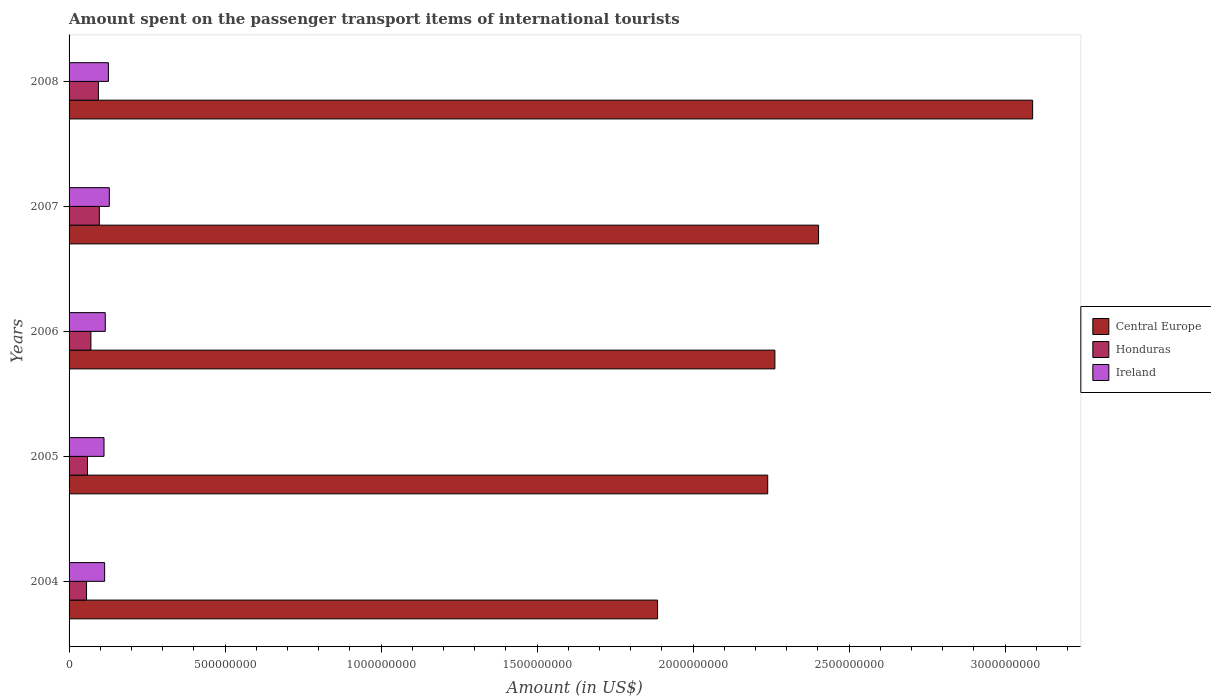How many different coloured bars are there?
Your response must be concise. 3. How many groups of bars are there?
Offer a terse response. 5. Are the number of bars on each tick of the Y-axis equal?
Your answer should be very brief. Yes. How many bars are there on the 5th tick from the top?
Provide a short and direct response. 3. How many bars are there on the 4th tick from the bottom?
Make the answer very short. 3. What is the label of the 5th group of bars from the top?
Offer a very short reply. 2004. In how many cases, is the number of bars for a given year not equal to the number of legend labels?
Give a very brief answer. 0. What is the amount spent on the passenger transport items of international tourists in Central Europe in 2007?
Keep it short and to the point. 2.40e+09. Across all years, what is the maximum amount spent on the passenger transport items of international tourists in Central Europe?
Your answer should be very brief. 3.09e+09. Across all years, what is the minimum amount spent on the passenger transport items of international tourists in Ireland?
Ensure brevity in your answer.  1.12e+08. In which year was the amount spent on the passenger transport items of international tourists in Central Europe maximum?
Offer a terse response. 2008. What is the total amount spent on the passenger transport items of international tourists in Honduras in the graph?
Provide a short and direct response. 3.76e+08. What is the difference between the amount spent on the passenger transport items of international tourists in Honduras in 2004 and that in 2005?
Offer a terse response. -3.00e+06. What is the difference between the amount spent on the passenger transport items of international tourists in Ireland in 2008 and the amount spent on the passenger transport items of international tourists in Honduras in 2007?
Ensure brevity in your answer.  2.90e+07. What is the average amount spent on the passenger transport items of international tourists in Ireland per year?
Provide a succinct answer. 1.19e+08. In the year 2008, what is the difference between the amount spent on the passenger transport items of international tourists in Central Europe and amount spent on the passenger transport items of international tourists in Honduras?
Offer a terse response. 2.99e+09. In how many years, is the amount spent on the passenger transport items of international tourists in Honduras greater than 200000000 US$?
Your response must be concise. 0. What is the ratio of the amount spent on the passenger transport items of international tourists in Ireland in 2005 to that in 2006?
Provide a short and direct response. 0.97. Is the amount spent on the passenger transport items of international tourists in Honduras in 2004 less than that in 2006?
Offer a very short reply. Yes. Is the difference between the amount spent on the passenger transport items of international tourists in Central Europe in 2005 and 2006 greater than the difference between the amount spent on the passenger transport items of international tourists in Honduras in 2005 and 2006?
Offer a terse response. No. What is the difference between the highest and the lowest amount spent on the passenger transport items of international tourists in Ireland?
Provide a succinct answer. 1.70e+07. In how many years, is the amount spent on the passenger transport items of international tourists in Honduras greater than the average amount spent on the passenger transport items of international tourists in Honduras taken over all years?
Provide a short and direct response. 2. Is the sum of the amount spent on the passenger transport items of international tourists in Central Europe in 2005 and 2008 greater than the maximum amount spent on the passenger transport items of international tourists in Honduras across all years?
Give a very brief answer. Yes. What does the 3rd bar from the top in 2008 represents?
Provide a succinct answer. Central Europe. What does the 3rd bar from the bottom in 2004 represents?
Ensure brevity in your answer.  Ireland. How many years are there in the graph?
Keep it short and to the point. 5. What is the difference between two consecutive major ticks on the X-axis?
Give a very brief answer. 5.00e+08. Are the values on the major ticks of X-axis written in scientific E-notation?
Keep it short and to the point. No. Does the graph contain any zero values?
Provide a short and direct response. No. Does the graph contain grids?
Offer a terse response. No. Where does the legend appear in the graph?
Keep it short and to the point. Center right. How are the legend labels stacked?
Your answer should be very brief. Vertical. What is the title of the graph?
Keep it short and to the point. Amount spent on the passenger transport items of international tourists. What is the Amount (in US$) of Central Europe in 2004?
Ensure brevity in your answer.  1.89e+09. What is the Amount (in US$) of Honduras in 2004?
Your answer should be very brief. 5.60e+07. What is the Amount (in US$) of Ireland in 2004?
Provide a short and direct response. 1.14e+08. What is the Amount (in US$) in Central Europe in 2005?
Provide a short and direct response. 2.24e+09. What is the Amount (in US$) of Honduras in 2005?
Keep it short and to the point. 5.90e+07. What is the Amount (in US$) in Ireland in 2005?
Offer a very short reply. 1.12e+08. What is the Amount (in US$) in Central Europe in 2006?
Keep it short and to the point. 2.26e+09. What is the Amount (in US$) of Honduras in 2006?
Make the answer very short. 7.00e+07. What is the Amount (in US$) of Ireland in 2006?
Offer a very short reply. 1.16e+08. What is the Amount (in US$) of Central Europe in 2007?
Your response must be concise. 2.40e+09. What is the Amount (in US$) in Honduras in 2007?
Ensure brevity in your answer.  9.70e+07. What is the Amount (in US$) in Ireland in 2007?
Provide a succinct answer. 1.29e+08. What is the Amount (in US$) of Central Europe in 2008?
Keep it short and to the point. 3.09e+09. What is the Amount (in US$) in Honduras in 2008?
Provide a short and direct response. 9.40e+07. What is the Amount (in US$) of Ireland in 2008?
Your answer should be compact. 1.26e+08. Across all years, what is the maximum Amount (in US$) in Central Europe?
Provide a succinct answer. 3.09e+09. Across all years, what is the maximum Amount (in US$) in Honduras?
Your answer should be compact. 9.70e+07. Across all years, what is the maximum Amount (in US$) in Ireland?
Provide a succinct answer. 1.29e+08. Across all years, what is the minimum Amount (in US$) of Central Europe?
Your response must be concise. 1.89e+09. Across all years, what is the minimum Amount (in US$) of Honduras?
Your answer should be very brief. 5.60e+07. Across all years, what is the minimum Amount (in US$) of Ireland?
Ensure brevity in your answer.  1.12e+08. What is the total Amount (in US$) of Central Europe in the graph?
Your answer should be compact. 1.19e+1. What is the total Amount (in US$) in Honduras in the graph?
Ensure brevity in your answer.  3.76e+08. What is the total Amount (in US$) in Ireland in the graph?
Provide a succinct answer. 5.97e+08. What is the difference between the Amount (in US$) in Central Europe in 2004 and that in 2005?
Ensure brevity in your answer.  -3.53e+08. What is the difference between the Amount (in US$) of Honduras in 2004 and that in 2005?
Make the answer very short. -3.00e+06. What is the difference between the Amount (in US$) in Central Europe in 2004 and that in 2006?
Ensure brevity in your answer.  -3.76e+08. What is the difference between the Amount (in US$) in Honduras in 2004 and that in 2006?
Ensure brevity in your answer.  -1.40e+07. What is the difference between the Amount (in US$) of Ireland in 2004 and that in 2006?
Provide a short and direct response. -2.00e+06. What is the difference between the Amount (in US$) in Central Europe in 2004 and that in 2007?
Offer a terse response. -5.16e+08. What is the difference between the Amount (in US$) in Honduras in 2004 and that in 2007?
Your response must be concise. -4.10e+07. What is the difference between the Amount (in US$) in Ireland in 2004 and that in 2007?
Offer a terse response. -1.50e+07. What is the difference between the Amount (in US$) of Central Europe in 2004 and that in 2008?
Your response must be concise. -1.20e+09. What is the difference between the Amount (in US$) of Honduras in 2004 and that in 2008?
Your answer should be very brief. -3.80e+07. What is the difference between the Amount (in US$) of Ireland in 2004 and that in 2008?
Ensure brevity in your answer.  -1.20e+07. What is the difference between the Amount (in US$) in Central Europe in 2005 and that in 2006?
Your response must be concise. -2.30e+07. What is the difference between the Amount (in US$) of Honduras in 2005 and that in 2006?
Keep it short and to the point. -1.10e+07. What is the difference between the Amount (in US$) of Central Europe in 2005 and that in 2007?
Your answer should be compact. -1.63e+08. What is the difference between the Amount (in US$) in Honduras in 2005 and that in 2007?
Your answer should be very brief. -3.80e+07. What is the difference between the Amount (in US$) in Ireland in 2005 and that in 2007?
Keep it short and to the point. -1.70e+07. What is the difference between the Amount (in US$) of Central Europe in 2005 and that in 2008?
Provide a succinct answer. -8.49e+08. What is the difference between the Amount (in US$) in Honduras in 2005 and that in 2008?
Provide a succinct answer. -3.50e+07. What is the difference between the Amount (in US$) of Ireland in 2005 and that in 2008?
Your response must be concise. -1.40e+07. What is the difference between the Amount (in US$) of Central Europe in 2006 and that in 2007?
Your answer should be very brief. -1.40e+08. What is the difference between the Amount (in US$) in Honduras in 2006 and that in 2007?
Give a very brief answer. -2.70e+07. What is the difference between the Amount (in US$) of Ireland in 2006 and that in 2007?
Keep it short and to the point. -1.30e+07. What is the difference between the Amount (in US$) in Central Europe in 2006 and that in 2008?
Make the answer very short. -8.26e+08. What is the difference between the Amount (in US$) of Honduras in 2006 and that in 2008?
Offer a very short reply. -2.40e+07. What is the difference between the Amount (in US$) of Ireland in 2006 and that in 2008?
Give a very brief answer. -1.00e+07. What is the difference between the Amount (in US$) in Central Europe in 2007 and that in 2008?
Give a very brief answer. -6.86e+08. What is the difference between the Amount (in US$) of Ireland in 2007 and that in 2008?
Keep it short and to the point. 3.00e+06. What is the difference between the Amount (in US$) of Central Europe in 2004 and the Amount (in US$) of Honduras in 2005?
Ensure brevity in your answer.  1.83e+09. What is the difference between the Amount (in US$) of Central Europe in 2004 and the Amount (in US$) of Ireland in 2005?
Keep it short and to the point. 1.77e+09. What is the difference between the Amount (in US$) in Honduras in 2004 and the Amount (in US$) in Ireland in 2005?
Provide a succinct answer. -5.60e+07. What is the difference between the Amount (in US$) in Central Europe in 2004 and the Amount (in US$) in Honduras in 2006?
Offer a terse response. 1.82e+09. What is the difference between the Amount (in US$) in Central Europe in 2004 and the Amount (in US$) in Ireland in 2006?
Your answer should be compact. 1.77e+09. What is the difference between the Amount (in US$) of Honduras in 2004 and the Amount (in US$) of Ireland in 2006?
Offer a very short reply. -6.00e+07. What is the difference between the Amount (in US$) in Central Europe in 2004 and the Amount (in US$) in Honduras in 2007?
Provide a short and direct response. 1.79e+09. What is the difference between the Amount (in US$) of Central Europe in 2004 and the Amount (in US$) of Ireland in 2007?
Your answer should be compact. 1.76e+09. What is the difference between the Amount (in US$) of Honduras in 2004 and the Amount (in US$) of Ireland in 2007?
Your answer should be compact. -7.30e+07. What is the difference between the Amount (in US$) of Central Europe in 2004 and the Amount (in US$) of Honduras in 2008?
Offer a very short reply. 1.79e+09. What is the difference between the Amount (in US$) in Central Europe in 2004 and the Amount (in US$) in Ireland in 2008?
Keep it short and to the point. 1.76e+09. What is the difference between the Amount (in US$) in Honduras in 2004 and the Amount (in US$) in Ireland in 2008?
Give a very brief answer. -7.00e+07. What is the difference between the Amount (in US$) of Central Europe in 2005 and the Amount (in US$) of Honduras in 2006?
Keep it short and to the point. 2.17e+09. What is the difference between the Amount (in US$) of Central Europe in 2005 and the Amount (in US$) of Ireland in 2006?
Offer a very short reply. 2.12e+09. What is the difference between the Amount (in US$) in Honduras in 2005 and the Amount (in US$) in Ireland in 2006?
Provide a short and direct response. -5.70e+07. What is the difference between the Amount (in US$) in Central Europe in 2005 and the Amount (in US$) in Honduras in 2007?
Ensure brevity in your answer.  2.14e+09. What is the difference between the Amount (in US$) of Central Europe in 2005 and the Amount (in US$) of Ireland in 2007?
Ensure brevity in your answer.  2.11e+09. What is the difference between the Amount (in US$) of Honduras in 2005 and the Amount (in US$) of Ireland in 2007?
Ensure brevity in your answer.  -7.00e+07. What is the difference between the Amount (in US$) of Central Europe in 2005 and the Amount (in US$) of Honduras in 2008?
Give a very brief answer. 2.14e+09. What is the difference between the Amount (in US$) in Central Europe in 2005 and the Amount (in US$) in Ireland in 2008?
Offer a very short reply. 2.11e+09. What is the difference between the Amount (in US$) of Honduras in 2005 and the Amount (in US$) of Ireland in 2008?
Your response must be concise. -6.70e+07. What is the difference between the Amount (in US$) of Central Europe in 2006 and the Amount (in US$) of Honduras in 2007?
Provide a succinct answer. 2.16e+09. What is the difference between the Amount (in US$) of Central Europe in 2006 and the Amount (in US$) of Ireland in 2007?
Ensure brevity in your answer.  2.13e+09. What is the difference between the Amount (in US$) in Honduras in 2006 and the Amount (in US$) in Ireland in 2007?
Make the answer very short. -5.90e+07. What is the difference between the Amount (in US$) of Central Europe in 2006 and the Amount (in US$) of Honduras in 2008?
Offer a very short reply. 2.17e+09. What is the difference between the Amount (in US$) of Central Europe in 2006 and the Amount (in US$) of Ireland in 2008?
Offer a very short reply. 2.14e+09. What is the difference between the Amount (in US$) of Honduras in 2006 and the Amount (in US$) of Ireland in 2008?
Give a very brief answer. -5.60e+07. What is the difference between the Amount (in US$) in Central Europe in 2007 and the Amount (in US$) in Honduras in 2008?
Give a very brief answer. 2.31e+09. What is the difference between the Amount (in US$) in Central Europe in 2007 and the Amount (in US$) in Ireland in 2008?
Provide a succinct answer. 2.28e+09. What is the difference between the Amount (in US$) of Honduras in 2007 and the Amount (in US$) of Ireland in 2008?
Offer a terse response. -2.90e+07. What is the average Amount (in US$) of Central Europe per year?
Your response must be concise. 2.38e+09. What is the average Amount (in US$) of Honduras per year?
Your response must be concise. 7.52e+07. What is the average Amount (in US$) in Ireland per year?
Your response must be concise. 1.19e+08. In the year 2004, what is the difference between the Amount (in US$) in Central Europe and Amount (in US$) in Honduras?
Make the answer very short. 1.83e+09. In the year 2004, what is the difference between the Amount (in US$) of Central Europe and Amount (in US$) of Ireland?
Keep it short and to the point. 1.77e+09. In the year 2004, what is the difference between the Amount (in US$) of Honduras and Amount (in US$) of Ireland?
Your response must be concise. -5.80e+07. In the year 2005, what is the difference between the Amount (in US$) in Central Europe and Amount (in US$) in Honduras?
Ensure brevity in your answer.  2.18e+09. In the year 2005, what is the difference between the Amount (in US$) of Central Europe and Amount (in US$) of Ireland?
Make the answer very short. 2.13e+09. In the year 2005, what is the difference between the Amount (in US$) in Honduras and Amount (in US$) in Ireland?
Make the answer very short. -5.30e+07. In the year 2006, what is the difference between the Amount (in US$) in Central Europe and Amount (in US$) in Honduras?
Make the answer very short. 2.19e+09. In the year 2006, what is the difference between the Amount (in US$) of Central Europe and Amount (in US$) of Ireland?
Provide a short and direct response. 2.15e+09. In the year 2006, what is the difference between the Amount (in US$) of Honduras and Amount (in US$) of Ireland?
Provide a short and direct response. -4.60e+07. In the year 2007, what is the difference between the Amount (in US$) of Central Europe and Amount (in US$) of Honduras?
Give a very brief answer. 2.30e+09. In the year 2007, what is the difference between the Amount (in US$) of Central Europe and Amount (in US$) of Ireland?
Your answer should be compact. 2.27e+09. In the year 2007, what is the difference between the Amount (in US$) of Honduras and Amount (in US$) of Ireland?
Provide a succinct answer. -3.20e+07. In the year 2008, what is the difference between the Amount (in US$) in Central Europe and Amount (in US$) in Honduras?
Your response must be concise. 2.99e+09. In the year 2008, what is the difference between the Amount (in US$) in Central Europe and Amount (in US$) in Ireland?
Offer a very short reply. 2.96e+09. In the year 2008, what is the difference between the Amount (in US$) in Honduras and Amount (in US$) in Ireland?
Make the answer very short. -3.20e+07. What is the ratio of the Amount (in US$) in Central Europe in 2004 to that in 2005?
Provide a short and direct response. 0.84. What is the ratio of the Amount (in US$) of Honduras in 2004 to that in 2005?
Make the answer very short. 0.95. What is the ratio of the Amount (in US$) in Ireland in 2004 to that in 2005?
Keep it short and to the point. 1.02. What is the ratio of the Amount (in US$) of Central Europe in 2004 to that in 2006?
Provide a short and direct response. 0.83. What is the ratio of the Amount (in US$) of Ireland in 2004 to that in 2006?
Make the answer very short. 0.98. What is the ratio of the Amount (in US$) in Central Europe in 2004 to that in 2007?
Ensure brevity in your answer.  0.79. What is the ratio of the Amount (in US$) of Honduras in 2004 to that in 2007?
Your answer should be very brief. 0.58. What is the ratio of the Amount (in US$) in Ireland in 2004 to that in 2007?
Provide a short and direct response. 0.88. What is the ratio of the Amount (in US$) of Central Europe in 2004 to that in 2008?
Provide a succinct answer. 0.61. What is the ratio of the Amount (in US$) in Honduras in 2004 to that in 2008?
Your answer should be compact. 0.6. What is the ratio of the Amount (in US$) of Ireland in 2004 to that in 2008?
Make the answer very short. 0.9. What is the ratio of the Amount (in US$) of Central Europe in 2005 to that in 2006?
Offer a terse response. 0.99. What is the ratio of the Amount (in US$) in Honduras in 2005 to that in 2006?
Provide a short and direct response. 0.84. What is the ratio of the Amount (in US$) in Ireland in 2005 to that in 2006?
Provide a succinct answer. 0.97. What is the ratio of the Amount (in US$) in Central Europe in 2005 to that in 2007?
Ensure brevity in your answer.  0.93. What is the ratio of the Amount (in US$) of Honduras in 2005 to that in 2007?
Make the answer very short. 0.61. What is the ratio of the Amount (in US$) of Ireland in 2005 to that in 2007?
Your answer should be compact. 0.87. What is the ratio of the Amount (in US$) of Central Europe in 2005 to that in 2008?
Your response must be concise. 0.73. What is the ratio of the Amount (in US$) in Honduras in 2005 to that in 2008?
Your answer should be compact. 0.63. What is the ratio of the Amount (in US$) in Central Europe in 2006 to that in 2007?
Your response must be concise. 0.94. What is the ratio of the Amount (in US$) in Honduras in 2006 to that in 2007?
Keep it short and to the point. 0.72. What is the ratio of the Amount (in US$) of Ireland in 2006 to that in 2007?
Offer a very short reply. 0.9. What is the ratio of the Amount (in US$) in Central Europe in 2006 to that in 2008?
Make the answer very short. 0.73. What is the ratio of the Amount (in US$) in Honduras in 2006 to that in 2008?
Give a very brief answer. 0.74. What is the ratio of the Amount (in US$) of Ireland in 2006 to that in 2008?
Ensure brevity in your answer.  0.92. What is the ratio of the Amount (in US$) in Honduras in 2007 to that in 2008?
Give a very brief answer. 1.03. What is the ratio of the Amount (in US$) in Ireland in 2007 to that in 2008?
Your answer should be very brief. 1.02. What is the difference between the highest and the second highest Amount (in US$) of Central Europe?
Your answer should be compact. 6.86e+08. What is the difference between the highest and the second highest Amount (in US$) of Ireland?
Give a very brief answer. 3.00e+06. What is the difference between the highest and the lowest Amount (in US$) of Central Europe?
Make the answer very short. 1.20e+09. What is the difference between the highest and the lowest Amount (in US$) in Honduras?
Offer a terse response. 4.10e+07. What is the difference between the highest and the lowest Amount (in US$) of Ireland?
Keep it short and to the point. 1.70e+07. 